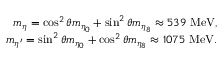<formula> <loc_0><loc_0><loc_500><loc_500>\begin{array} { r l r } & { m _ { \eta } = \cos ^ { 2 } \theta m _ { \eta _ { 0 } } + \sin ^ { 2 } \theta m _ { \eta _ { 8 } } \approx 5 3 9 \ { M e V } , } \\ & { m _ { \eta ^ { \prime } } = \sin ^ { 2 } \theta m _ { \eta _ { 0 } } + \cos ^ { 2 } \theta m _ { \eta _ { 8 } } \approx 1 0 7 5 \ { M e V } . } \end{array}</formula> 